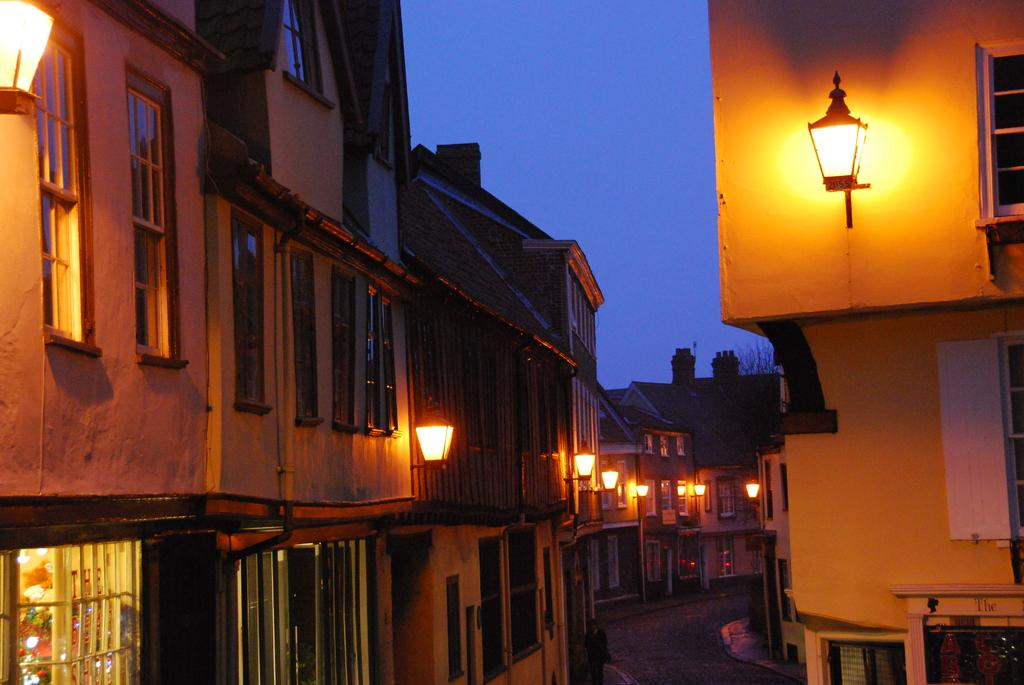What type of structures can be seen in the image? There are buildings in the image. What else is visible in the image besides the buildings? There are lights, trees, a road, and sky visible in the image. Can you describe the road in the image? The road is at the bottom of the image. What is visible at the top of the image? The sky is visible at the top of the image. How many legs does the bell have in the image? There is no bell present in the image. What type of line can be seen connecting the trees in the image? There is no line connecting the trees in the image; the trees are separate entities. 